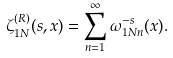Convert formula to latex. <formula><loc_0><loc_0><loc_500><loc_500>\zeta _ { 1 N } ^ { ( R ) } ( s , x ) = \sum _ { n = 1 } ^ { \infty } \omega _ { 1 N n } ^ { - s } ( x ) .</formula> 